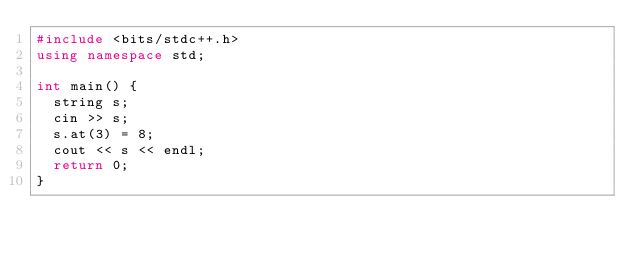<code> <loc_0><loc_0><loc_500><loc_500><_C++_>#include <bits/stdc++.h>
using namespace std;

int main() {
  string s;
  cin >> s;
  s.at(3) = 8;
  cout << s << endl;
  return 0;
}
</code> 